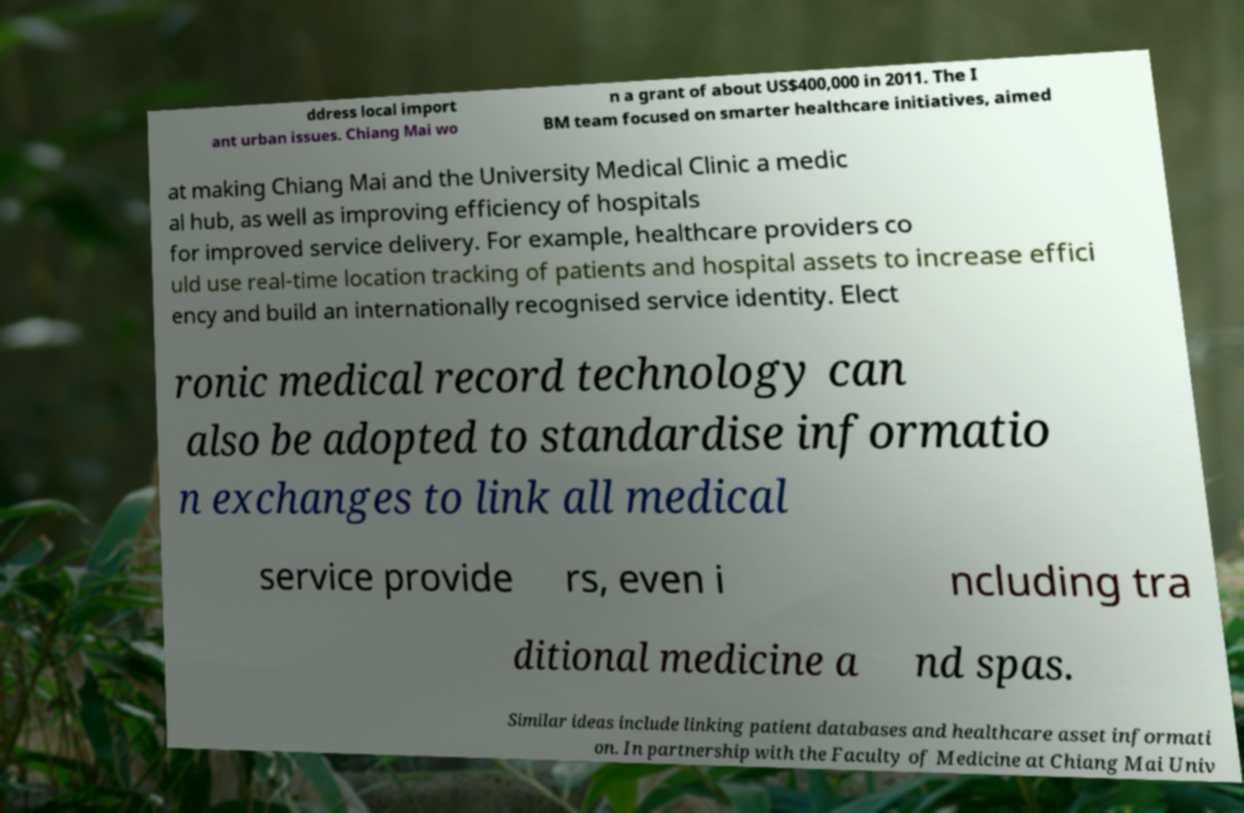For documentation purposes, I need the text within this image transcribed. Could you provide that? ddress local import ant urban issues. Chiang Mai wo n a grant of about US$400,000 in 2011. The I BM team focused on smarter healthcare initiatives, aimed at making Chiang Mai and the University Medical Clinic a medic al hub, as well as improving efficiency of hospitals for improved service delivery. For example, healthcare providers co uld use real-time location tracking of patients and hospital assets to increase effici ency and build an internationally recognised service identity. Elect ronic medical record technology can also be adopted to standardise informatio n exchanges to link all medical service provide rs, even i ncluding tra ditional medicine a nd spas. Similar ideas include linking patient databases and healthcare asset informati on. In partnership with the Faculty of Medicine at Chiang Mai Univ 